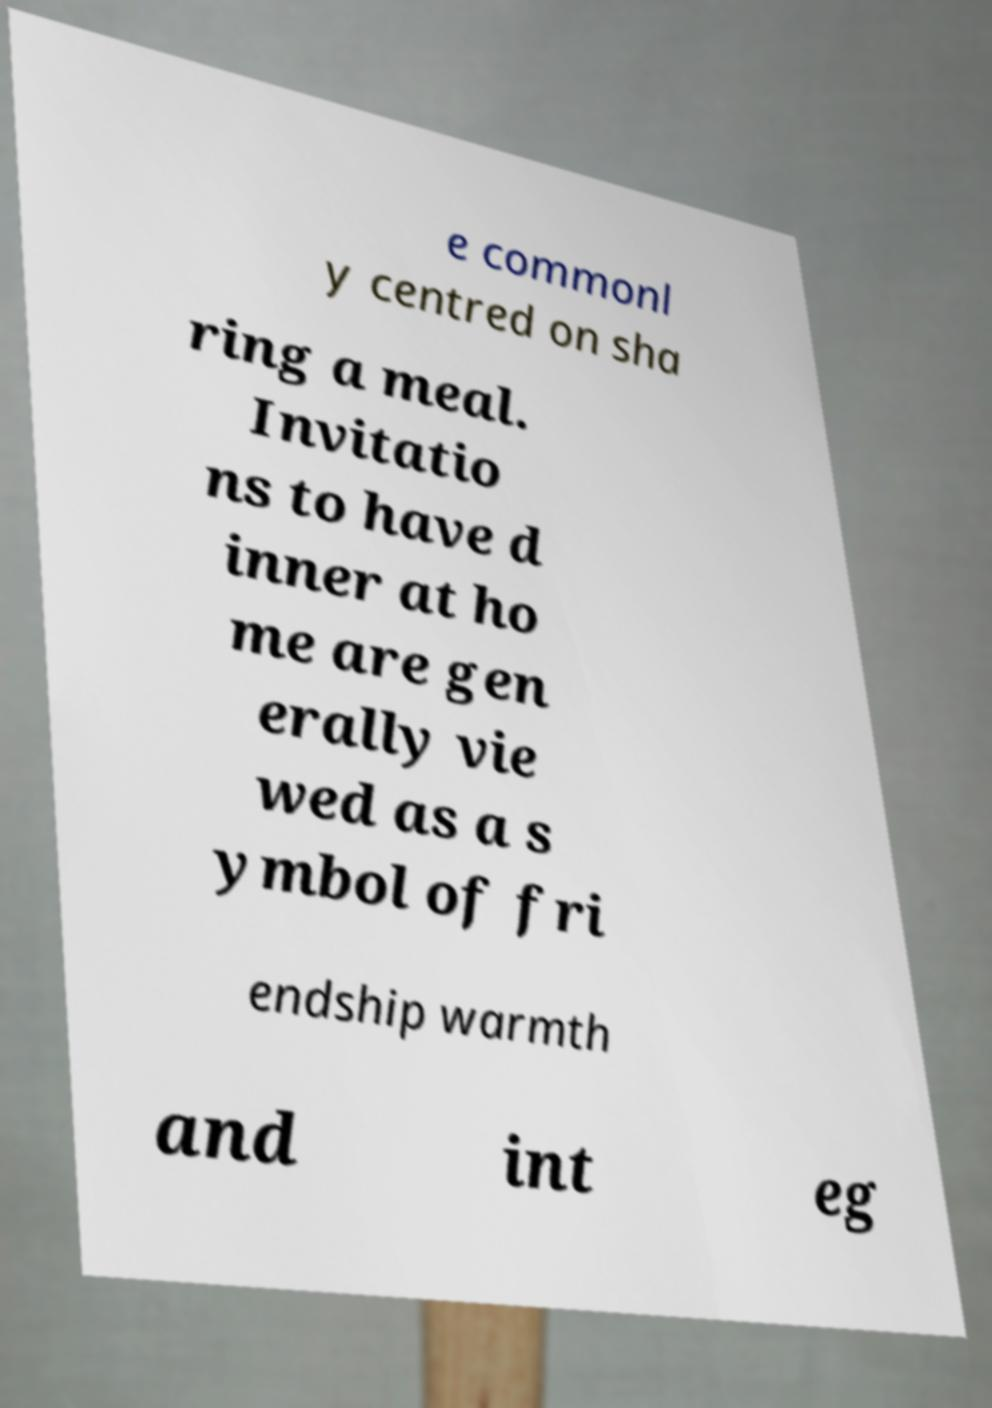For documentation purposes, I need the text within this image transcribed. Could you provide that? e commonl y centred on sha ring a meal. Invitatio ns to have d inner at ho me are gen erally vie wed as a s ymbol of fri endship warmth and int eg 